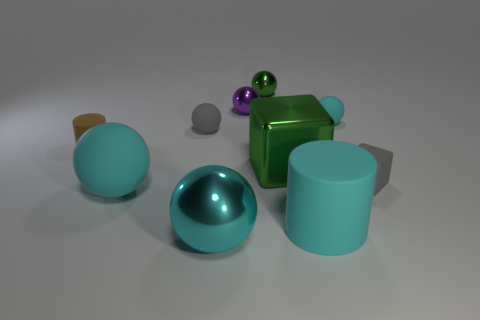What number of other objects are the same material as the brown cylinder?
Keep it short and to the point. 5. There is a cyan matte ball behind the gray matte thing that is right of the large metal cube; what number of cyan things are on the left side of it?
Your answer should be very brief. 3. How many metallic things are purple cubes or small cylinders?
Make the answer very short. 0. There is a cylinder that is to the left of the rubber cylinder right of the gray matte ball; what is its size?
Your answer should be very brief. Small. There is a cylinder in front of the brown matte cylinder; does it have the same color as the matte cylinder left of the purple ball?
Offer a terse response. No. What color is the shiny object that is to the left of the big metal block and in front of the small brown cylinder?
Your answer should be very brief. Cyan. Are the small purple thing and the tiny brown cylinder made of the same material?
Your answer should be very brief. No. What number of tiny things are gray matte spheres or rubber cylinders?
Keep it short and to the point. 2. Are there any other things that are the same shape as the purple metallic object?
Your response must be concise. Yes. Is there anything else that is the same size as the purple metal sphere?
Offer a terse response. Yes. 